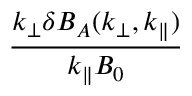Convert formula to latex. <formula><loc_0><loc_0><loc_500><loc_500>\frac { k _ { \perp } \delta B _ { A } ( k _ { \perp } , k _ { \| } ) } { k _ { \| } B _ { 0 } }</formula> 